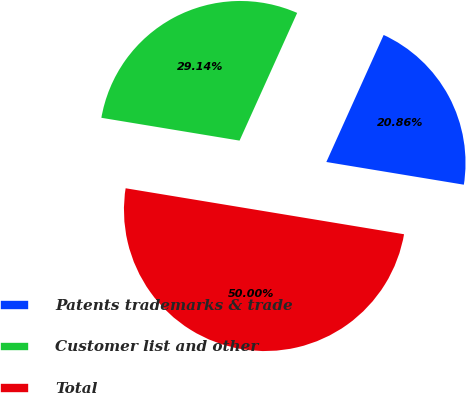Convert chart. <chart><loc_0><loc_0><loc_500><loc_500><pie_chart><fcel>Patents trademarks & trade<fcel>Customer list and other<fcel>Total<nl><fcel>20.86%<fcel>29.14%<fcel>50.0%<nl></chart> 